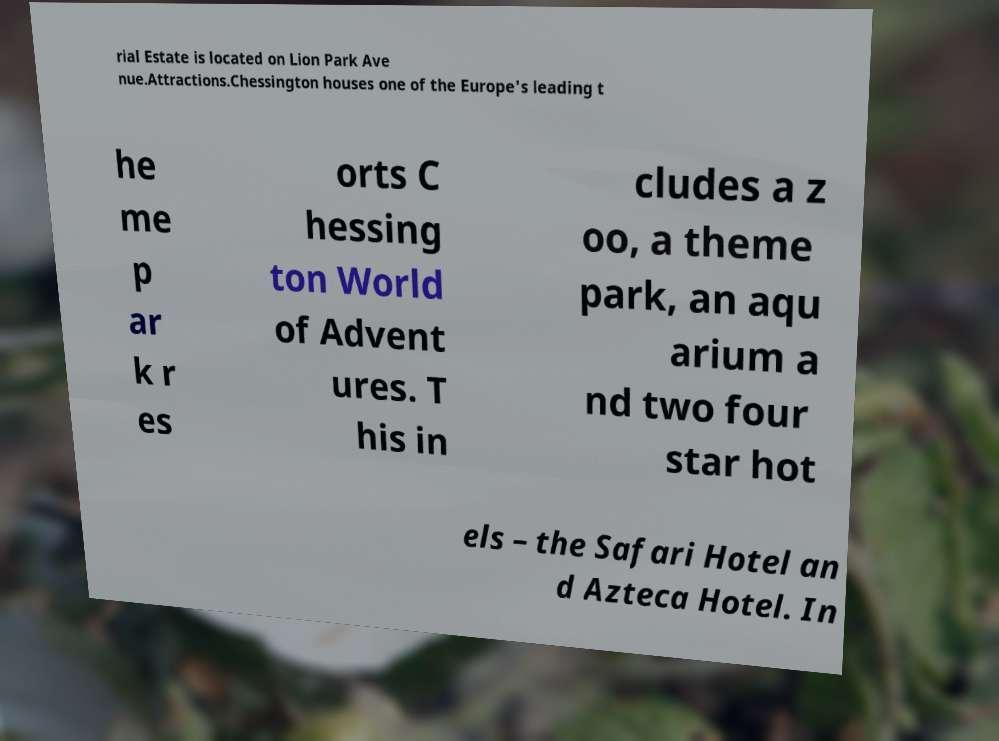I need the written content from this picture converted into text. Can you do that? rial Estate is located on Lion Park Ave nue.Attractions.Chessington houses one of the Europe's leading t he me p ar k r es orts C hessing ton World of Advent ures. T his in cludes a z oo, a theme park, an aqu arium a nd two four star hot els – the Safari Hotel an d Azteca Hotel. In 